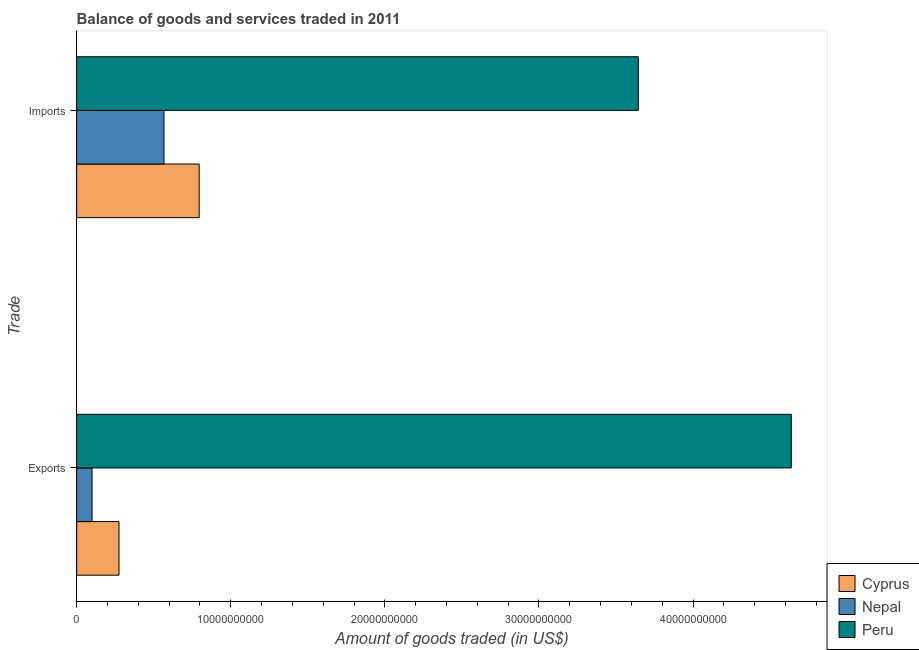How many groups of bars are there?
Your response must be concise. 2. Are the number of bars on each tick of the Y-axis equal?
Make the answer very short. Yes. What is the label of the 2nd group of bars from the top?
Your response must be concise. Exports. What is the amount of goods exported in Cyprus?
Your answer should be compact. 2.75e+09. Across all countries, what is the maximum amount of goods exported?
Your response must be concise. 4.64e+1. Across all countries, what is the minimum amount of goods imported?
Ensure brevity in your answer.  5.67e+09. In which country was the amount of goods exported maximum?
Ensure brevity in your answer.  Peru. In which country was the amount of goods imported minimum?
Give a very brief answer. Nepal. What is the total amount of goods imported in the graph?
Offer a terse response. 5.01e+1. What is the difference between the amount of goods imported in Peru and that in Nepal?
Your answer should be compact. 3.08e+1. What is the difference between the amount of goods exported in Peru and the amount of goods imported in Cyprus?
Your answer should be very brief. 3.84e+1. What is the average amount of goods exported per country?
Make the answer very short. 1.67e+1. What is the difference between the amount of goods imported and amount of goods exported in Nepal?
Your response must be concise. 4.67e+09. In how many countries, is the amount of goods exported greater than 46000000000 US$?
Make the answer very short. 1. What is the ratio of the amount of goods imported in Cyprus to that in Nepal?
Keep it short and to the point. 1.4. Is the amount of goods imported in Cyprus less than that in Peru?
Your response must be concise. Yes. In how many countries, is the amount of goods imported greater than the average amount of goods imported taken over all countries?
Your response must be concise. 1. What does the 3rd bar from the top in Imports represents?
Give a very brief answer. Cyprus. How many bars are there?
Keep it short and to the point. 6. Are all the bars in the graph horizontal?
Offer a very short reply. Yes. How many countries are there in the graph?
Offer a terse response. 3. What is the difference between two consecutive major ticks on the X-axis?
Give a very brief answer. 1.00e+1. Does the graph contain any zero values?
Make the answer very short. No. How many legend labels are there?
Your answer should be compact. 3. What is the title of the graph?
Offer a very short reply. Balance of goods and services traded in 2011. Does "San Marino" appear as one of the legend labels in the graph?
Offer a terse response. No. What is the label or title of the X-axis?
Your answer should be compact. Amount of goods traded (in US$). What is the label or title of the Y-axis?
Keep it short and to the point. Trade. What is the Amount of goods traded (in US$) in Cyprus in Exports?
Your response must be concise. 2.75e+09. What is the Amount of goods traded (in US$) in Nepal in Exports?
Offer a very short reply. 9.99e+08. What is the Amount of goods traded (in US$) in Peru in Exports?
Your response must be concise. 4.64e+1. What is the Amount of goods traded (in US$) in Cyprus in Imports?
Your answer should be compact. 7.95e+09. What is the Amount of goods traded (in US$) in Nepal in Imports?
Your answer should be very brief. 5.67e+09. What is the Amount of goods traded (in US$) in Peru in Imports?
Provide a succinct answer. 3.64e+1. Across all Trade, what is the maximum Amount of goods traded (in US$) of Cyprus?
Your answer should be very brief. 7.95e+09. Across all Trade, what is the maximum Amount of goods traded (in US$) of Nepal?
Provide a short and direct response. 5.67e+09. Across all Trade, what is the maximum Amount of goods traded (in US$) of Peru?
Offer a very short reply. 4.64e+1. Across all Trade, what is the minimum Amount of goods traded (in US$) in Cyprus?
Your response must be concise. 2.75e+09. Across all Trade, what is the minimum Amount of goods traded (in US$) of Nepal?
Provide a short and direct response. 9.99e+08. Across all Trade, what is the minimum Amount of goods traded (in US$) of Peru?
Provide a succinct answer. 3.64e+1. What is the total Amount of goods traded (in US$) of Cyprus in the graph?
Offer a very short reply. 1.07e+1. What is the total Amount of goods traded (in US$) of Nepal in the graph?
Ensure brevity in your answer.  6.66e+09. What is the total Amount of goods traded (in US$) of Peru in the graph?
Give a very brief answer. 8.28e+1. What is the difference between the Amount of goods traded (in US$) in Cyprus in Exports and that in Imports?
Keep it short and to the point. -5.20e+09. What is the difference between the Amount of goods traded (in US$) of Nepal in Exports and that in Imports?
Your answer should be very brief. -4.67e+09. What is the difference between the Amount of goods traded (in US$) in Peru in Exports and that in Imports?
Your response must be concise. 9.93e+09. What is the difference between the Amount of goods traded (in US$) in Cyprus in Exports and the Amount of goods traded (in US$) in Nepal in Imports?
Make the answer very short. -2.92e+09. What is the difference between the Amount of goods traded (in US$) of Cyprus in Exports and the Amount of goods traded (in US$) of Peru in Imports?
Give a very brief answer. -3.37e+1. What is the difference between the Amount of goods traded (in US$) of Nepal in Exports and the Amount of goods traded (in US$) of Peru in Imports?
Ensure brevity in your answer.  -3.54e+1. What is the average Amount of goods traded (in US$) in Cyprus per Trade?
Your response must be concise. 5.35e+09. What is the average Amount of goods traded (in US$) of Nepal per Trade?
Your answer should be very brief. 3.33e+09. What is the average Amount of goods traded (in US$) of Peru per Trade?
Offer a terse response. 4.14e+1. What is the difference between the Amount of goods traded (in US$) in Cyprus and Amount of goods traded (in US$) in Nepal in Exports?
Provide a short and direct response. 1.75e+09. What is the difference between the Amount of goods traded (in US$) of Cyprus and Amount of goods traded (in US$) of Peru in Exports?
Offer a very short reply. -4.36e+1. What is the difference between the Amount of goods traded (in US$) of Nepal and Amount of goods traded (in US$) of Peru in Exports?
Ensure brevity in your answer.  -4.54e+1. What is the difference between the Amount of goods traded (in US$) in Cyprus and Amount of goods traded (in US$) in Nepal in Imports?
Give a very brief answer. 2.29e+09. What is the difference between the Amount of goods traded (in US$) of Cyprus and Amount of goods traded (in US$) of Peru in Imports?
Your response must be concise. -2.85e+1. What is the difference between the Amount of goods traded (in US$) of Nepal and Amount of goods traded (in US$) of Peru in Imports?
Your response must be concise. -3.08e+1. What is the ratio of the Amount of goods traded (in US$) of Cyprus in Exports to that in Imports?
Provide a short and direct response. 0.35. What is the ratio of the Amount of goods traded (in US$) of Nepal in Exports to that in Imports?
Your answer should be very brief. 0.18. What is the ratio of the Amount of goods traded (in US$) in Peru in Exports to that in Imports?
Keep it short and to the point. 1.27. What is the difference between the highest and the second highest Amount of goods traded (in US$) of Cyprus?
Your answer should be very brief. 5.20e+09. What is the difference between the highest and the second highest Amount of goods traded (in US$) of Nepal?
Your answer should be very brief. 4.67e+09. What is the difference between the highest and the second highest Amount of goods traded (in US$) of Peru?
Give a very brief answer. 9.93e+09. What is the difference between the highest and the lowest Amount of goods traded (in US$) in Cyprus?
Ensure brevity in your answer.  5.20e+09. What is the difference between the highest and the lowest Amount of goods traded (in US$) of Nepal?
Provide a succinct answer. 4.67e+09. What is the difference between the highest and the lowest Amount of goods traded (in US$) in Peru?
Offer a terse response. 9.93e+09. 